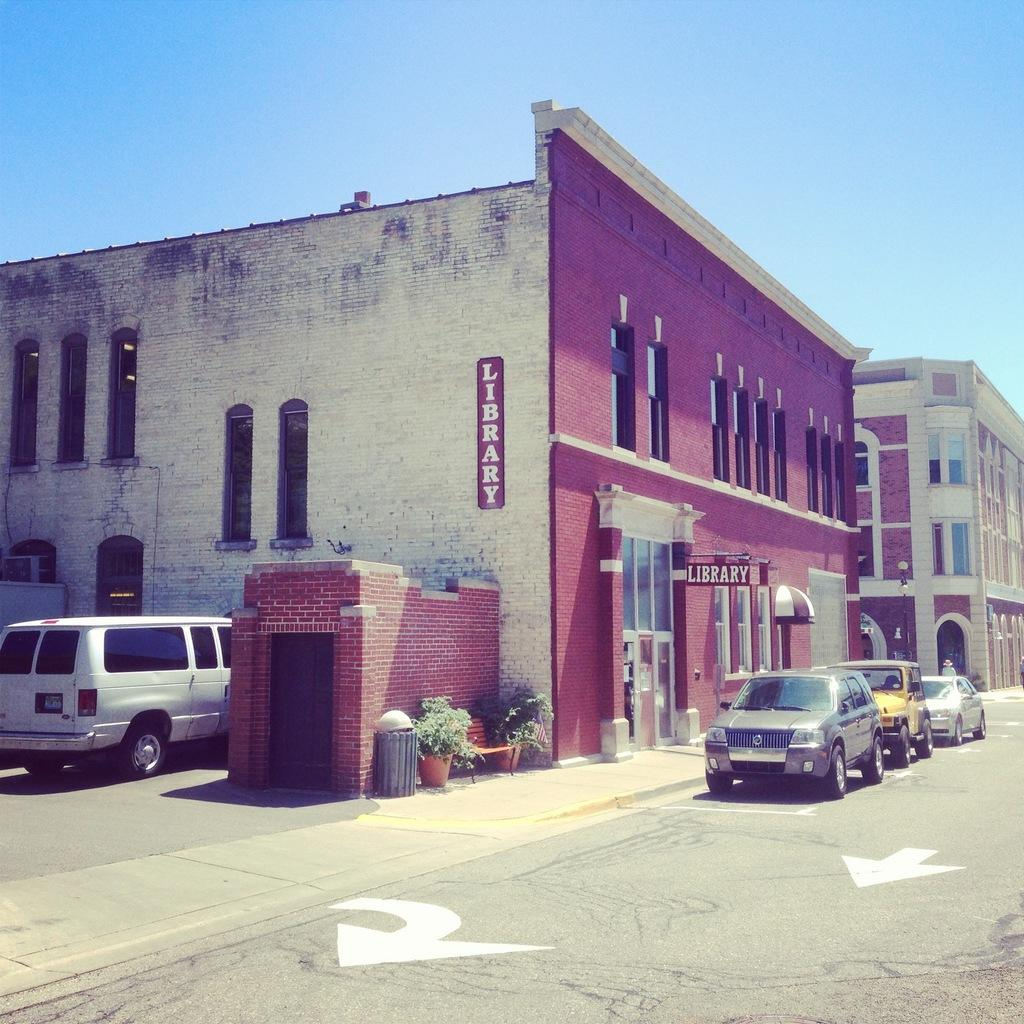What type of structures can be seen in the image? There are buildings in the image. What feature can be found on some of the buildings? There are windows in the image. What else is present in the image besides buildings and windows? There are vehicles, plants, and pots in the image. What can be seen at the top of the image? The sky is visible at the top of the image. What type of chin can be seen on the plants in the image? There are no chins present in the image, as plants do not have chins. What type of jelly is being used to decorate the vehicles in the image? There is no jelly present in the image, and the vehicles are not being decorated with any jelly. 